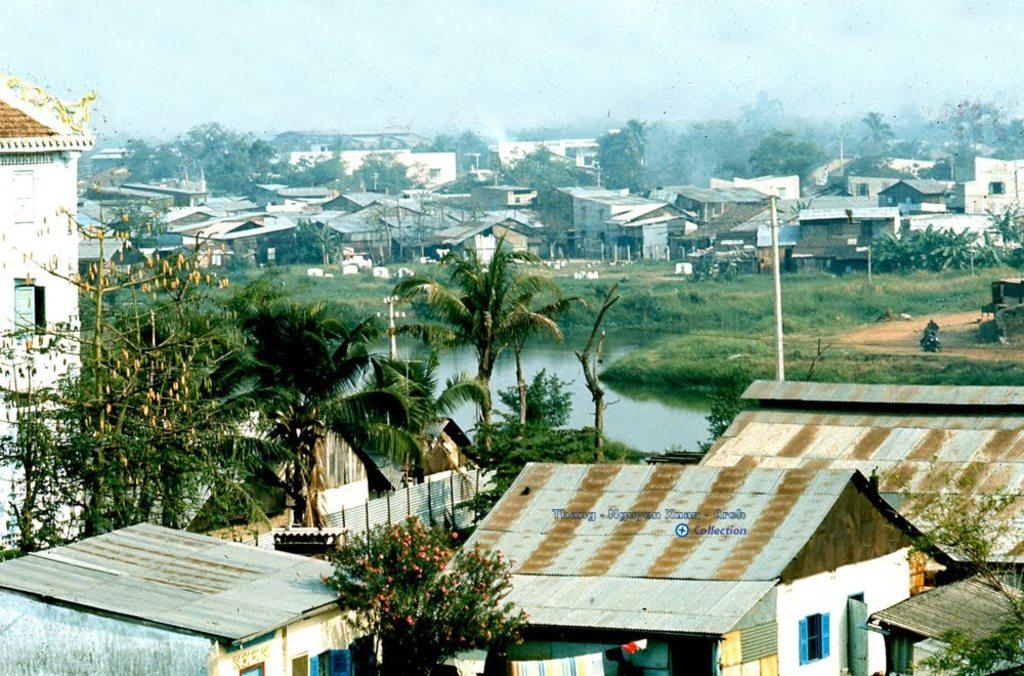What type of structures can be seen in the image? There are houses in the image. What type of vegetation is present in the image? There are trees in the image. What are the tall, thin objects in the image? There are poles in the image. What natural element is visible in the image? There is water visible in the image. What is the belief of the trees in the image? Trees do not have beliefs, as they are inanimate objects. How many times has the water been bitten by the houses in the image? The water cannot be bitten, and houses do not have the ability to bite. 